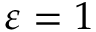Convert formula to latex. <formula><loc_0><loc_0><loc_500><loc_500>\varepsilon = 1</formula> 